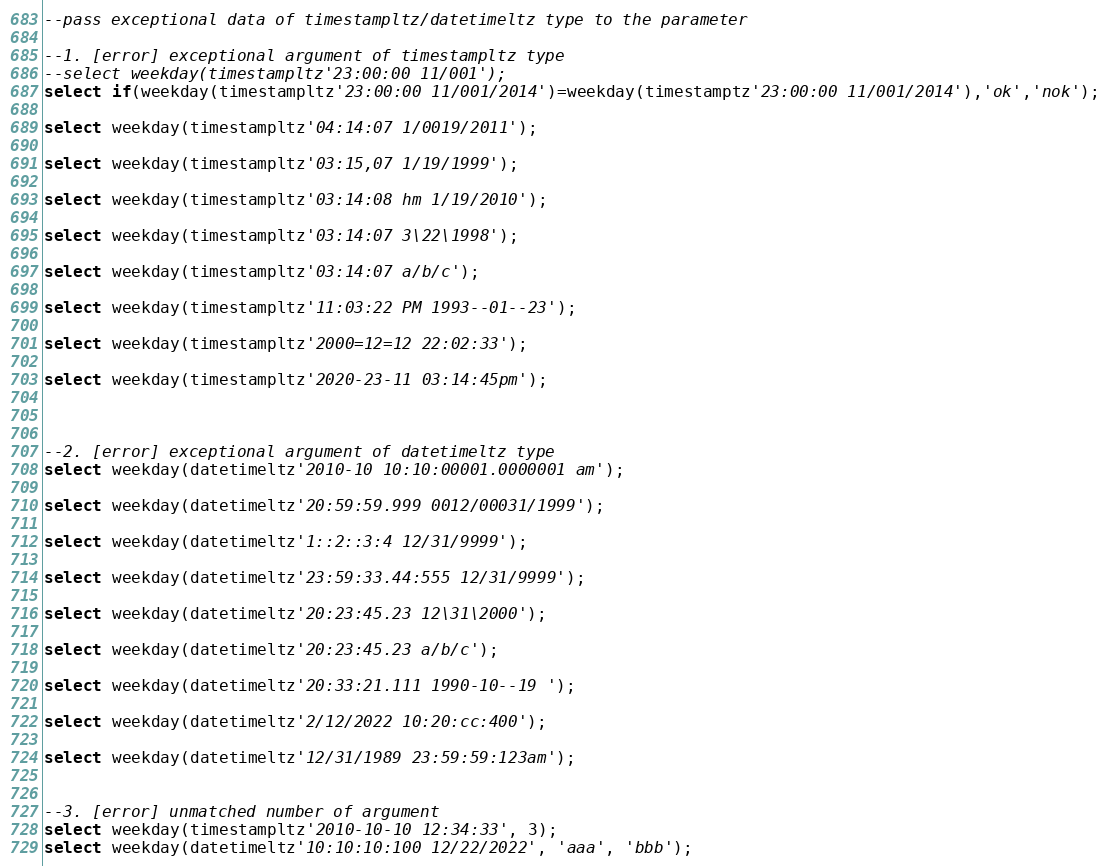Convert code to text. <code><loc_0><loc_0><loc_500><loc_500><_SQL_>--pass exceptional data of timestampltz/datetimeltz type to the parameter

--1. [error] exceptional argument of timestampltz type
--select weekday(timestampltz'23:00:00 11/001');
select if(weekday(timestampltz'23:00:00 11/001/2014')=weekday(timestamptz'23:00:00 11/001/2014'),'ok','nok');

select weekday(timestampltz'04:14:07 1/0019/2011');

select weekday(timestampltz'03:15,07 1/19/1999');

select weekday(timestampltz'03:14:08 hm 1/19/2010');

select weekday(timestampltz'03:14:07 3\22\1998');

select weekday(timestampltz'03:14:07 a/b/c');

select weekday(timestampltz'11:03:22 PM 1993--01--23');

select weekday(timestampltz'2000=12=12 22:02:33');

select weekday(timestampltz'2020-23-11 03:14:45pm');



--2. [error] exceptional argument of datetimeltz type
select weekday(datetimeltz'2010-10 10:10:00001.0000001 am');

select weekday(datetimeltz'20:59:59.999 0012/00031/1999');

select weekday(datetimeltz'1::2::3:4 12/31/9999');

select weekday(datetimeltz'23:59:33.44:555 12/31/9999');

select weekday(datetimeltz'20:23:45.23 12\31\2000');

select weekday(datetimeltz'20:23:45.23 a/b/c');

select weekday(datetimeltz'20:33:21.111 1990-10--19 ');

select weekday(datetimeltz'2/12/2022 10:20:cc:400');

select weekday(datetimeltz'12/31/1989 23:59:59:123am');


--3. [error] unmatched number of argument
select weekday(timestampltz'2010-10-10 12:34:33', 3);
select weekday(datetimeltz'10:10:10:100 12/22/2022', 'aaa', 'bbb');
</code> 